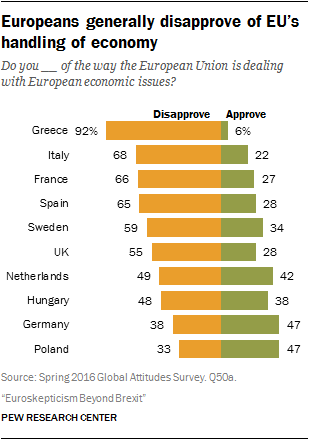Outline some significant characteristics in this image. The value of the first two green bars from the bottom is 47. The median of the orange bar is greater than the largest green bar. 